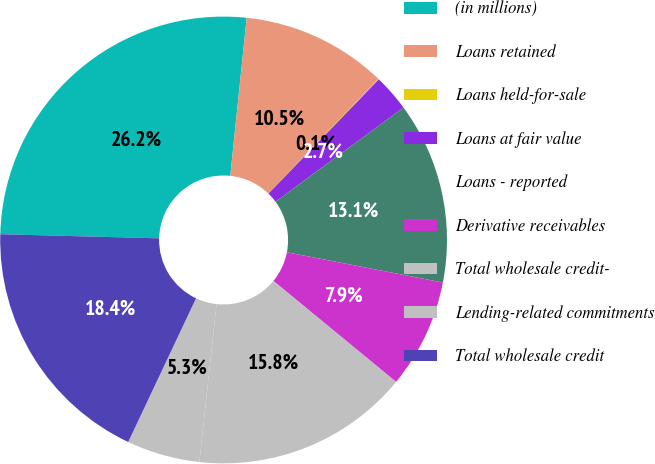Convert chart to OTSL. <chart><loc_0><loc_0><loc_500><loc_500><pie_chart><fcel>(in millions)<fcel>Loans retained<fcel>Loans held-for-sale<fcel>Loans at fair value<fcel>Loans - reported<fcel>Derivative receivables<fcel>Total wholesale credit-<fcel>Lending-related commitments<fcel>Total wholesale credit<nl><fcel>26.24%<fcel>10.53%<fcel>0.05%<fcel>2.67%<fcel>13.15%<fcel>7.91%<fcel>15.77%<fcel>5.29%<fcel>18.39%<nl></chart> 